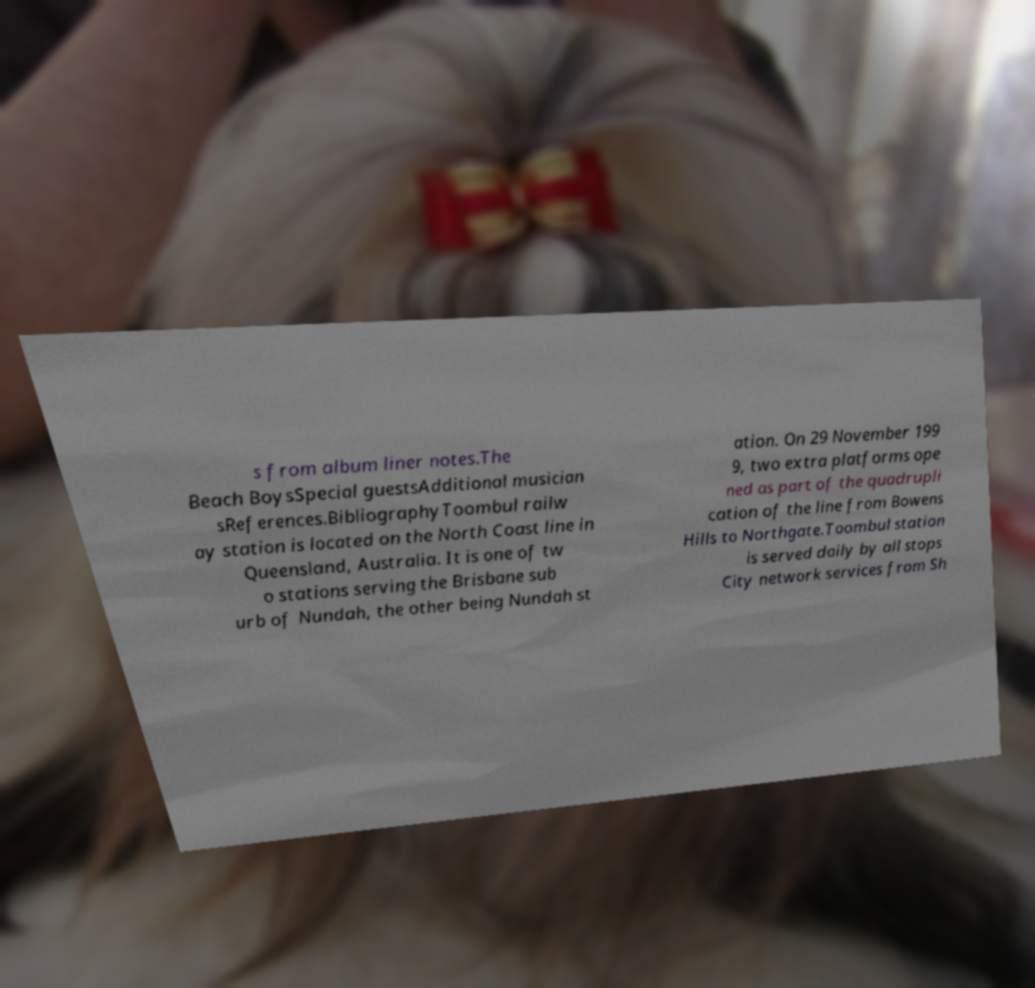There's text embedded in this image that I need extracted. Can you transcribe it verbatim? s from album liner notes.The Beach BoysSpecial guestsAdditional musician sReferences.BibliographyToombul railw ay station is located on the North Coast line in Queensland, Australia. It is one of tw o stations serving the Brisbane sub urb of Nundah, the other being Nundah st ation. On 29 November 199 9, two extra platforms ope ned as part of the quadrupli cation of the line from Bowens Hills to Northgate.Toombul station is served daily by all stops City network services from Sh 